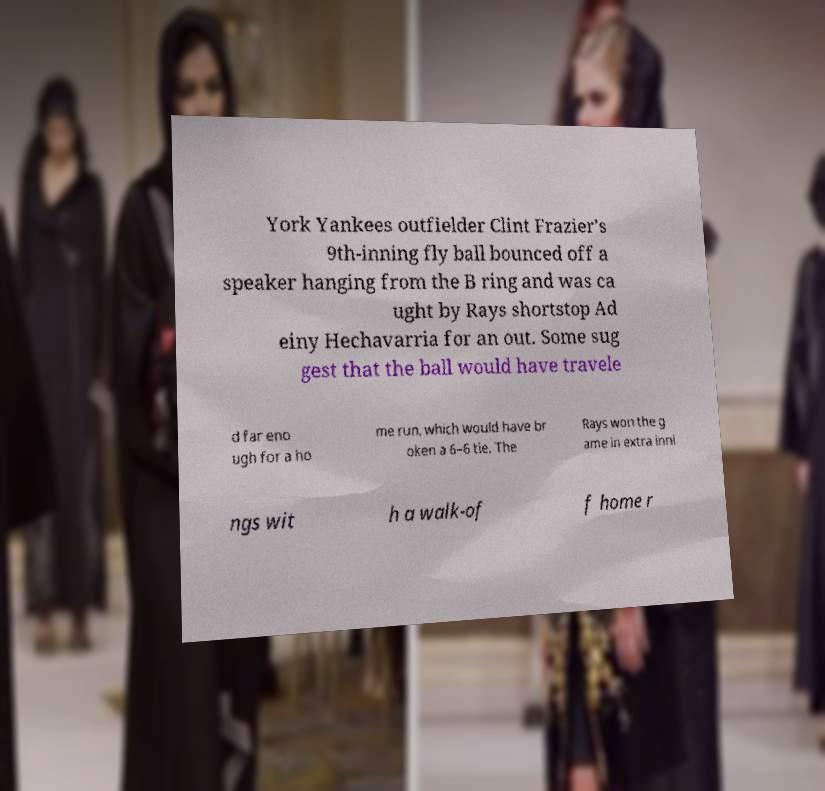For documentation purposes, I need the text within this image transcribed. Could you provide that? York Yankees outfielder Clint Frazier's 9th-inning fly ball bounced off a speaker hanging from the B ring and was ca ught by Rays shortstop Ad einy Hechavarria for an out. Some sug gest that the ball would have travele d far eno ugh for a ho me run, which would have br oken a 6–6 tie. The Rays won the g ame in extra inni ngs wit h a walk-of f home r 